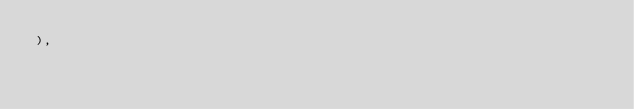Convert code to text. <code><loc_0><loc_0><loc_500><loc_500><_Dart_>),
</code> 